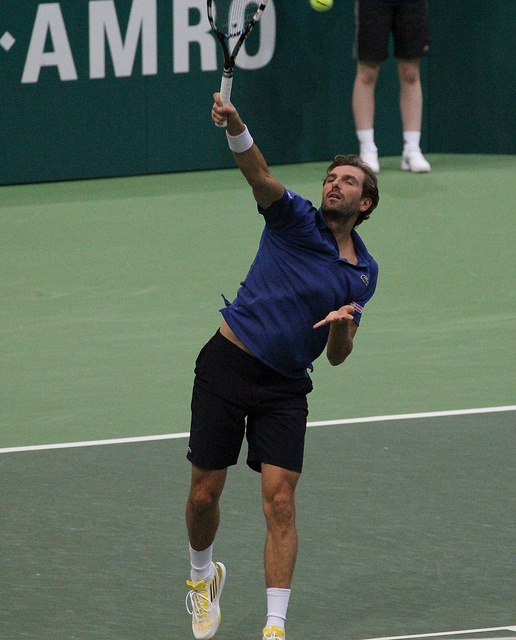Describe the objects in this image and their specific colors. I can see people in darkblue, black, navy, gray, and brown tones, people in darkblue, black, gray, and lavender tones, tennis racket in darkblue, black, darkgray, gray, and purple tones, and sports ball in darkblue, darkgreen, and olive tones in this image. 